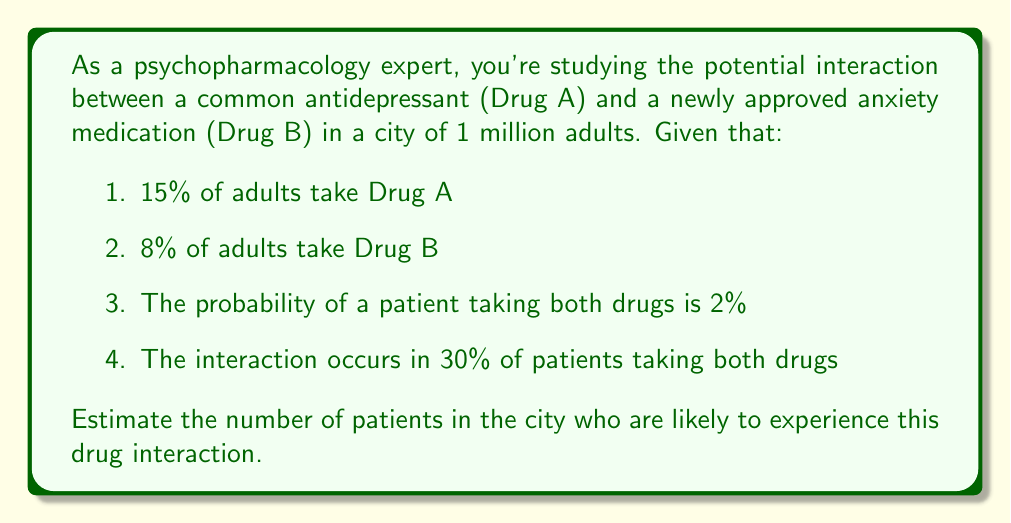Can you answer this question? Let's approach this problem step-by-step:

1. First, we need to calculate the number of patients taking both Drug A and Drug B.

   Let's define:
   $A$: event of taking Drug A
   $B$: event of taking Drug B

   Given:
   $P(A) = 15\% = 0.15$
   $P(B) = 8\% = 0.08$
   $P(A \text{ and } B) = 2\% = 0.02$

2. The number of patients taking both drugs in a city of 1 million adults:

   $N(\text{both}) = 1,000,000 \times 0.02 = 20,000$ patients

3. Now, we need to calculate how many of these patients are likely to experience the interaction.

   Given: The interaction occurs in 30% of patients taking both drugs.

   $N(\text{interaction}) = 20,000 \times 0.30 = 6,000$ patients

Therefore, an estimated 6,000 patients in the city are likely to experience this drug interaction.
Answer: 6,000 patients 